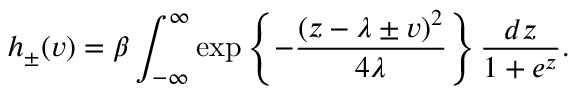Convert formula to latex. <formula><loc_0><loc_0><loc_500><loc_500>h _ { \pm } ( v ) = \beta \int _ { - \infty } ^ { \infty } \exp \left \{ - \frac { ( z - \lambda \pm v ) ^ { 2 } } { 4 \lambda } \right \} \frac { d z } { 1 + e ^ { z } } .</formula> 